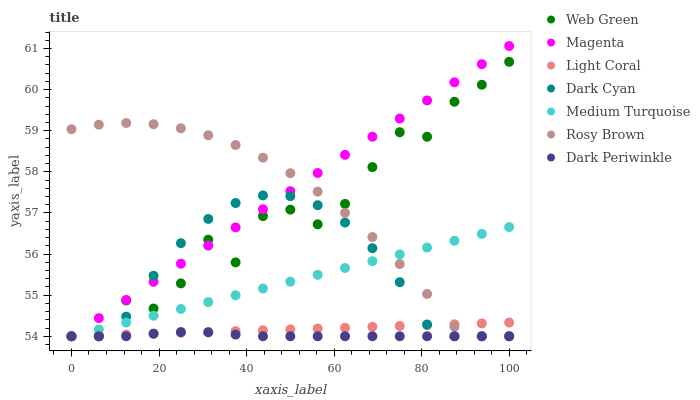Does Dark Periwinkle have the minimum area under the curve?
Answer yes or no. Yes. Does Magenta have the maximum area under the curve?
Answer yes or no. Yes. Does Web Green have the minimum area under the curve?
Answer yes or no. No. Does Web Green have the maximum area under the curve?
Answer yes or no. No. Is Light Coral the smoothest?
Answer yes or no. Yes. Is Web Green the roughest?
Answer yes or no. Yes. Is Web Green the smoothest?
Answer yes or no. No. Is Light Coral the roughest?
Answer yes or no. No. Does Rosy Brown have the lowest value?
Answer yes or no. Yes. Does Magenta have the highest value?
Answer yes or no. Yes. Does Web Green have the highest value?
Answer yes or no. No. Does Magenta intersect Dark Periwinkle?
Answer yes or no. Yes. Is Magenta less than Dark Periwinkle?
Answer yes or no. No. Is Magenta greater than Dark Periwinkle?
Answer yes or no. No. 